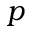<formula> <loc_0><loc_0><loc_500><loc_500>p</formula> 